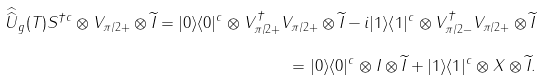<formula> <loc_0><loc_0><loc_500><loc_500>\widehat { \widehat { U } } _ { g } ( T ) S ^ { \dagger c } \otimes V _ { \pi / 2 + } \otimes \widetilde { I } = | 0 \rangle \langle 0 | ^ { c } \otimes V _ { \pi / 2 + } ^ { \dagger } V _ { \pi / 2 + } \otimes \widetilde { I } - i | 1 \rangle \langle 1 | ^ { c } \otimes V _ { \pi / 2 - } ^ { \dagger } V _ { \pi / 2 + } \otimes \widetilde { I } \\ = | 0 \rangle \langle 0 | ^ { c } \otimes I \otimes \widetilde { I } + | 1 \rangle \langle 1 | ^ { c } \otimes X \otimes \widetilde { I } .</formula> 